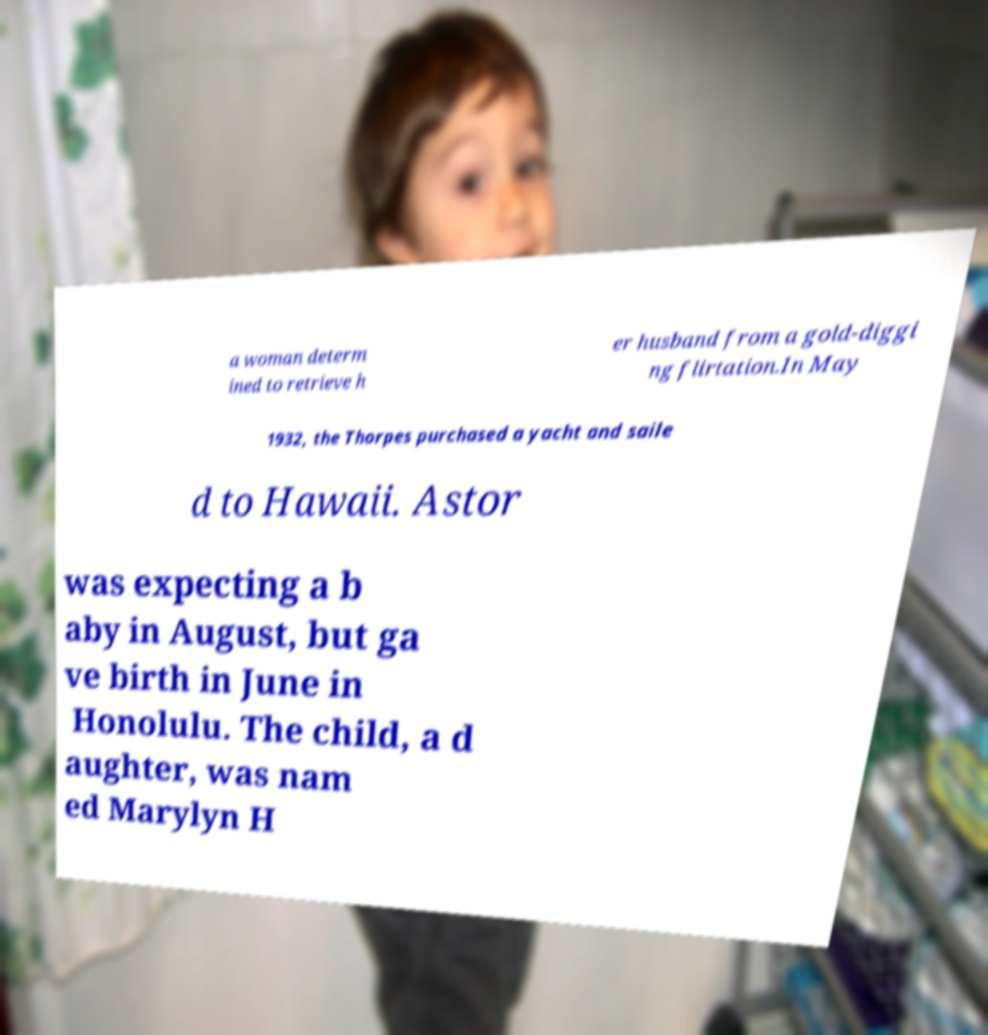Can you accurately transcribe the text from the provided image for me? a woman determ ined to retrieve h er husband from a gold-diggi ng flirtation.In May 1932, the Thorpes purchased a yacht and saile d to Hawaii. Astor was expecting a b aby in August, but ga ve birth in June in Honolulu. The child, a d aughter, was nam ed Marylyn H 